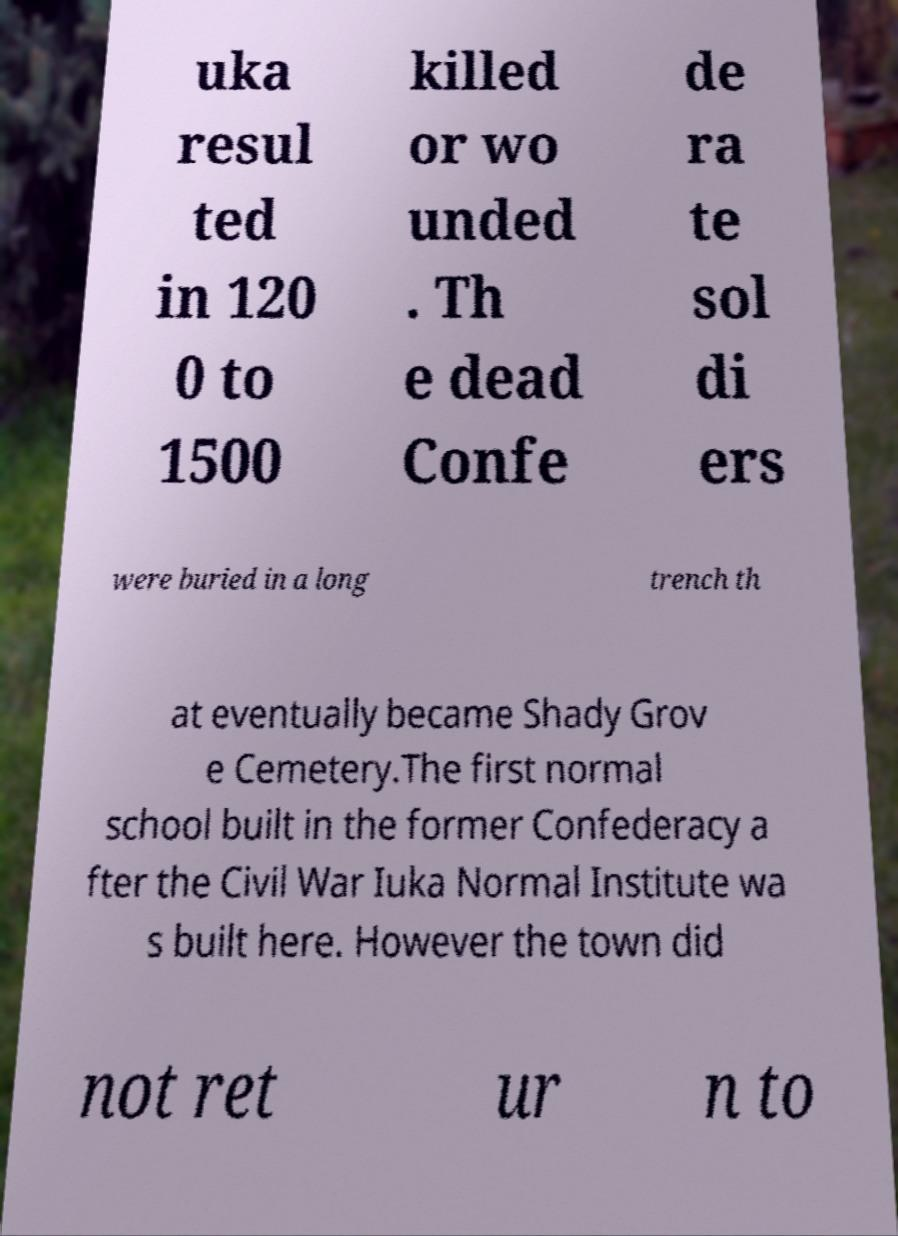Can you read and provide the text displayed in the image?This photo seems to have some interesting text. Can you extract and type it out for me? uka resul ted in 120 0 to 1500 killed or wo unded . Th e dead Confe de ra te sol di ers were buried in a long trench th at eventually became Shady Grov e Cemetery.The first normal school built in the former Confederacy a fter the Civil War Iuka Normal Institute wa s built here. However the town did not ret ur n to 